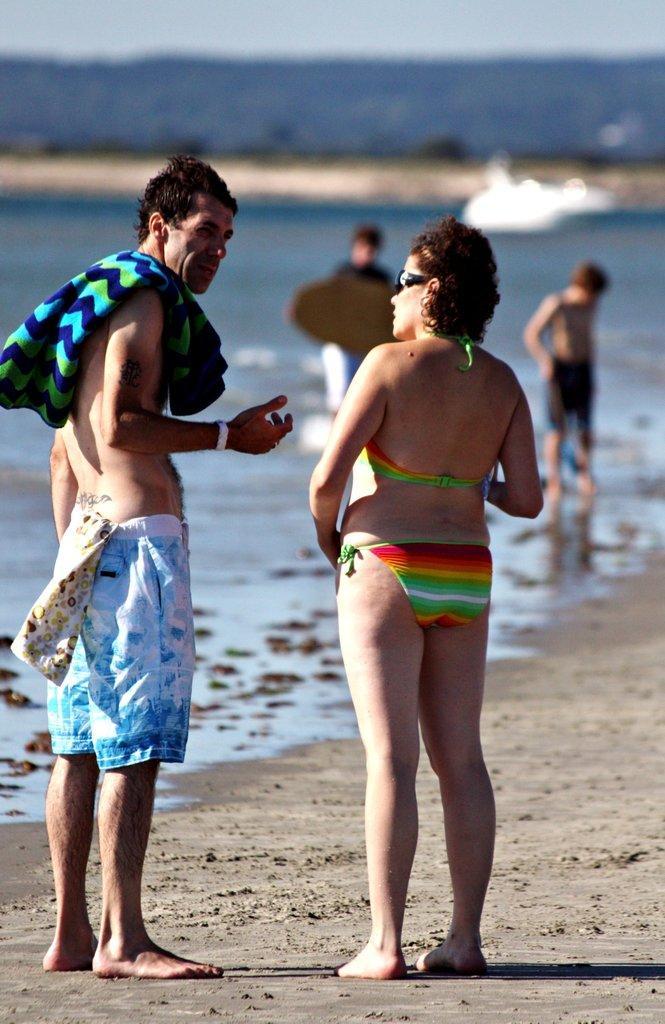Can you describe this image briefly? In this picture i can see a man and a woman are standing. The man is wearing shorts and carrying towel. In the background i can see water, people and sky. 